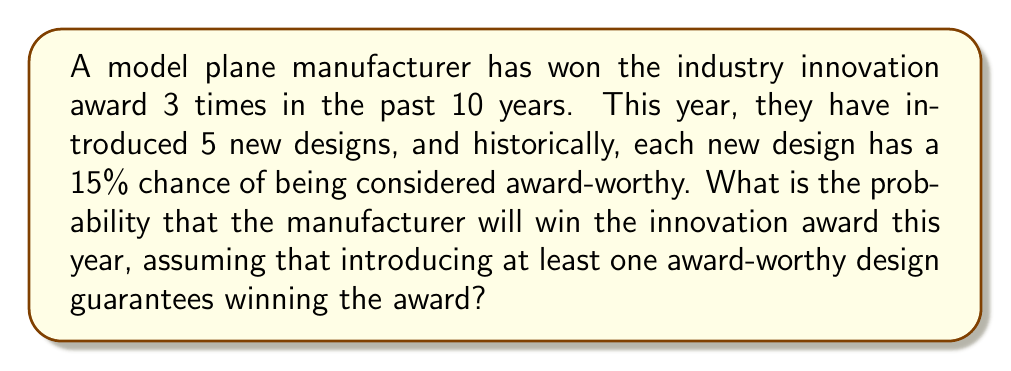Give your solution to this math problem. Let's approach this step-by-step:

1) First, we need to calculate the probability of at least one of the new designs being award-worthy.

2) It's easier to calculate the probability of no designs being award-worthy and then subtract this from 1.

3) The probability of a single design not being award-worthy is $1 - 0.15 = 0.85$ or 85%.

4) For all 5 designs to not be award-worthy, each must independently not be award-worthy. We can express this as:

   $P(\text{no award-worthy designs}) = 0.85^5$

5) Let's calculate this:
   
   $0.85^5 \approx 0.4437$

6) Therefore, the probability of at least one design being award-worthy is:

   $P(\text{at least one award-worthy design}) = 1 - 0.4437 = 0.5563$

7) Since introducing at least one award-worthy design guarantees winning the award, this is also the probability of winning the award this year.

8) We can express this as a percentage: $0.5563 \times 100\% \approx 55.63\%$
Answer: 55.63% 